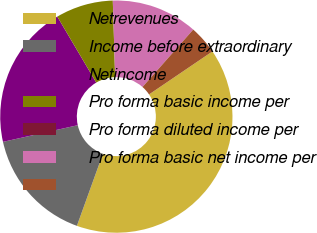Convert chart to OTSL. <chart><loc_0><loc_0><loc_500><loc_500><pie_chart><fcel>Netrevenues<fcel>Income before extraordinary<fcel>Netincome<fcel>Pro forma basic income per<fcel>Pro forma diluted income per<fcel>Pro forma basic net income per<fcel>Unnamed: 6<nl><fcel>40.0%<fcel>16.0%<fcel>20.0%<fcel>8.0%<fcel>0.0%<fcel>12.0%<fcel>4.0%<nl></chart> 